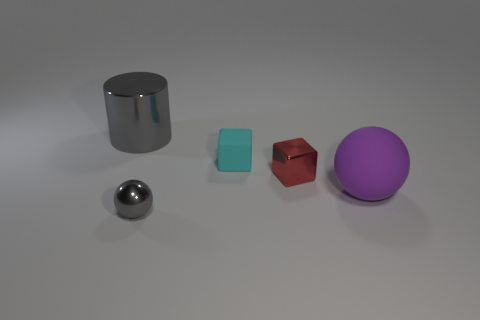Add 3 big purple matte cylinders. How many objects exist? 8 Subtract all purple spheres. How many spheres are left? 1 Subtract all cubes. How many objects are left? 3 Subtract all red spheres. Subtract all yellow blocks. How many spheres are left? 2 Subtract all big cyan rubber blocks. Subtract all big purple rubber objects. How many objects are left? 4 Add 4 red blocks. How many red blocks are left? 5 Add 5 small red metallic blocks. How many small red metallic blocks exist? 6 Subtract 0 purple cubes. How many objects are left? 5 